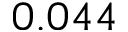<formula> <loc_0><loc_0><loc_500><loc_500>0 . 0 4 4</formula> 